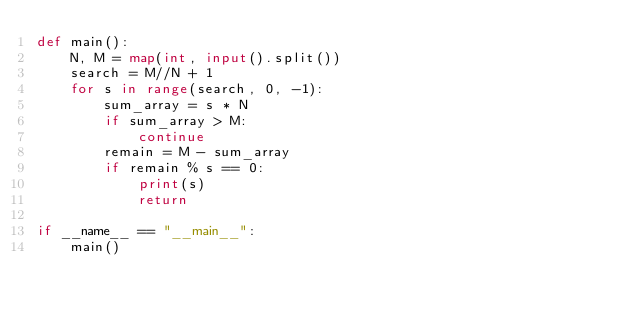Convert code to text. <code><loc_0><loc_0><loc_500><loc_500><_Python_>def main():
    N, M = map(int, input().split())
    search = M//N + 1
    for s in range(search, 0, -1):
        sum_array = s * N
        if sum_array > M:
            continue
        remain = M - sum_array
        if remain % s == 0:
            print(s)
            return

if __name__ == "__main__":
    main()
</code> 